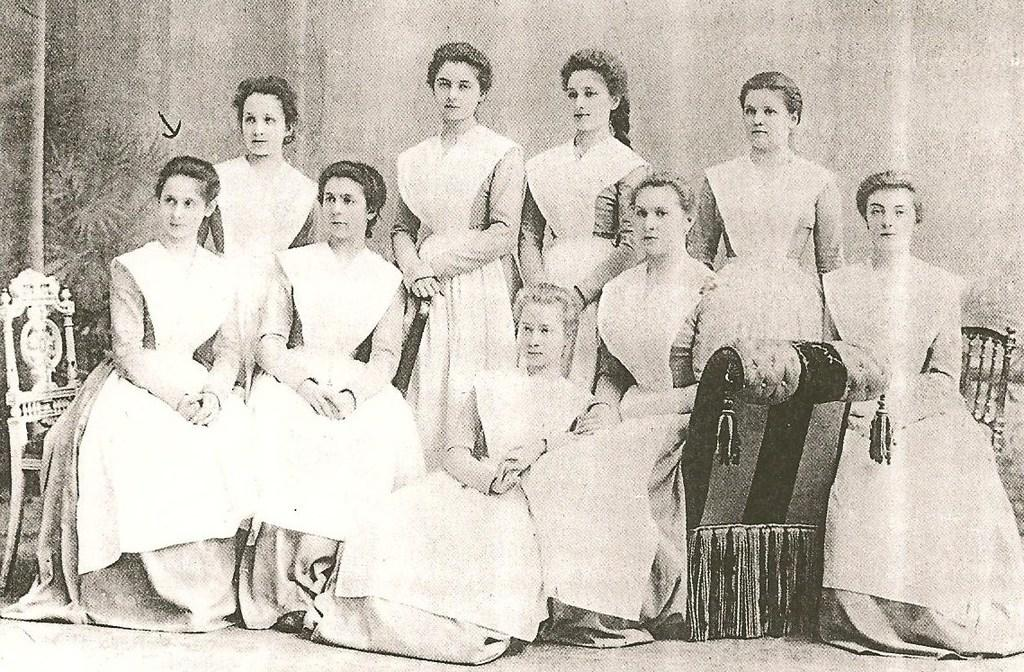What are the people in the image doing? There are people sitting on a couch and standing in the image. What type of furniture is present in the image? There are chairs in the image. What is the color scheme of the image? The image is in black and white. What type of pancake is being served on the zinc table in the image? There is no pancake or zinc table present in the image. What type of net is being used to catch the ball in the image? There is no ball or net present in the image. 